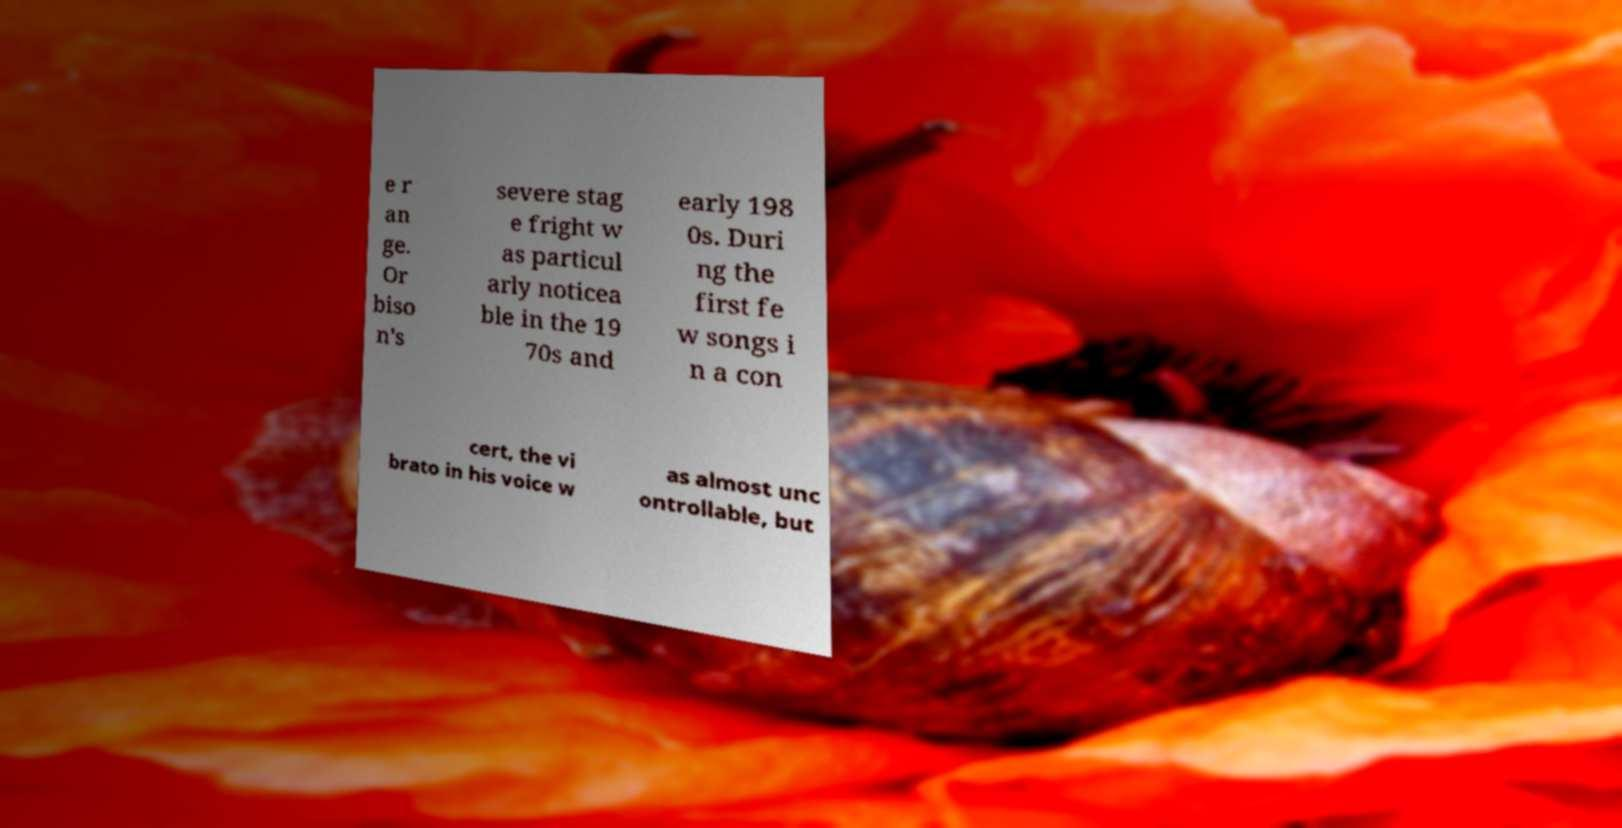For documentation purposes, I need the text within this image transcribed. Could you provide that? e r an ge. Or biso n's severe stag e fright w as particul arly noticea ble in the 19 70s and early 198 0s. Duri ng the first fe w songs i n a con cert, the vi brato in his voice w as almost unc ontrollable, but 